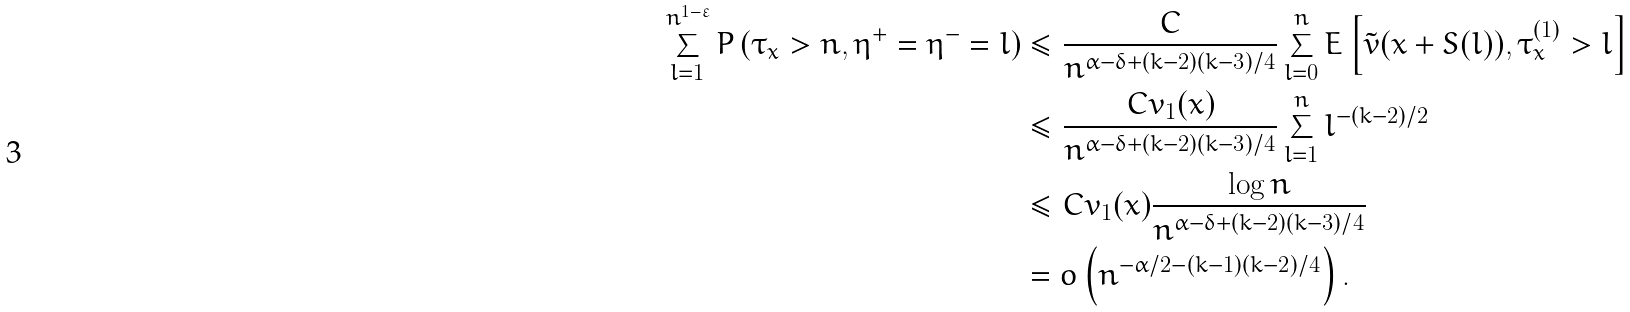Convert formula to latex. <formula><loc_0><loc_0><loc_500><loc_500>\sum _ { l = 1 } ^ { n ^ { 1 - \varepsilon } } P \left ( \tau _ { x } > n , \eta ^ { + } = \eta ^ { - } = l \right ) & \leq \frac { C } { n ^ { \alpha - \delta + ( k - 2 ) ( k - 3 ) / 4 } } \sum _ { l = 0 } ^ { n } E \left [ \tilde { v } ( x + S ( l ) ) , \tau _ { x } ^ { ( 1 ) } > l \right ] \\ & \leq \frac { C v _ { 1 } ( x ) } { n ^ { \alpha - \delta + ( k - 2 ) ( k - 3 ) / 4 } } \sum _ { l = 1 } ^ { n } l ^ { - ( k - 2 ) / 2 } \\ & \leq C v _ { 1 } ( x ) \frac { \log n } { n ^ { \alpha - \delta + ( k - 2 ) ( k - 3 ) / 4 } } \\ & = o \left ( n ^ { - \alpha / 2 - ( k - 1 ) ( k - 2 ) / 4 } \right ) .</formula> 